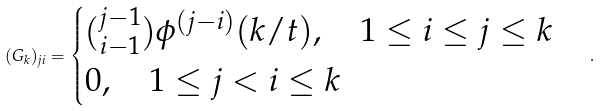<formula> <loc_0><loc_0><loc_500><loc_500>( G _ { k } ) _ { j i } = \begin{cases} { j - 1 \choose i - 1 } \phi ^ { ( j - i ) } ( k / t ) , \quad 1 \leq i \leq j \leq k \\ 0 , \quad 1 \leq j < i \leq k \end{cases} .</formula> 